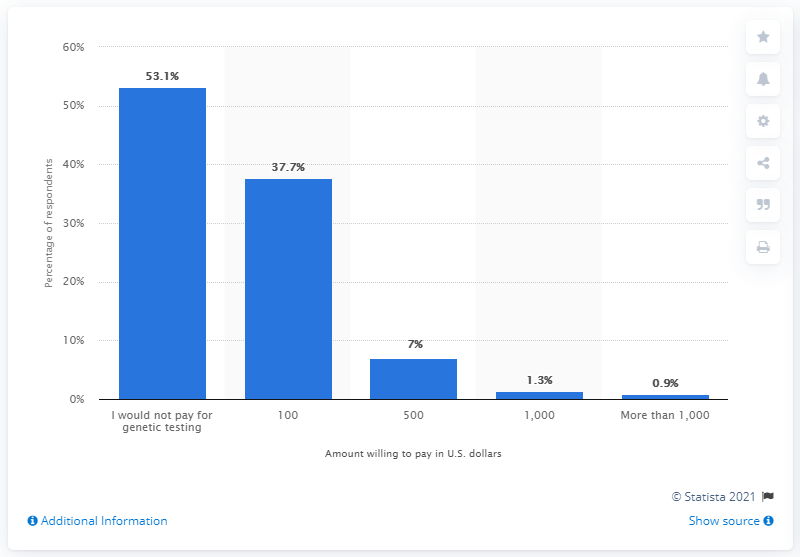Give some essential details in this illustration. According to a survey of Americans, 37.7% said they would be willing to pay for genetic testing. 